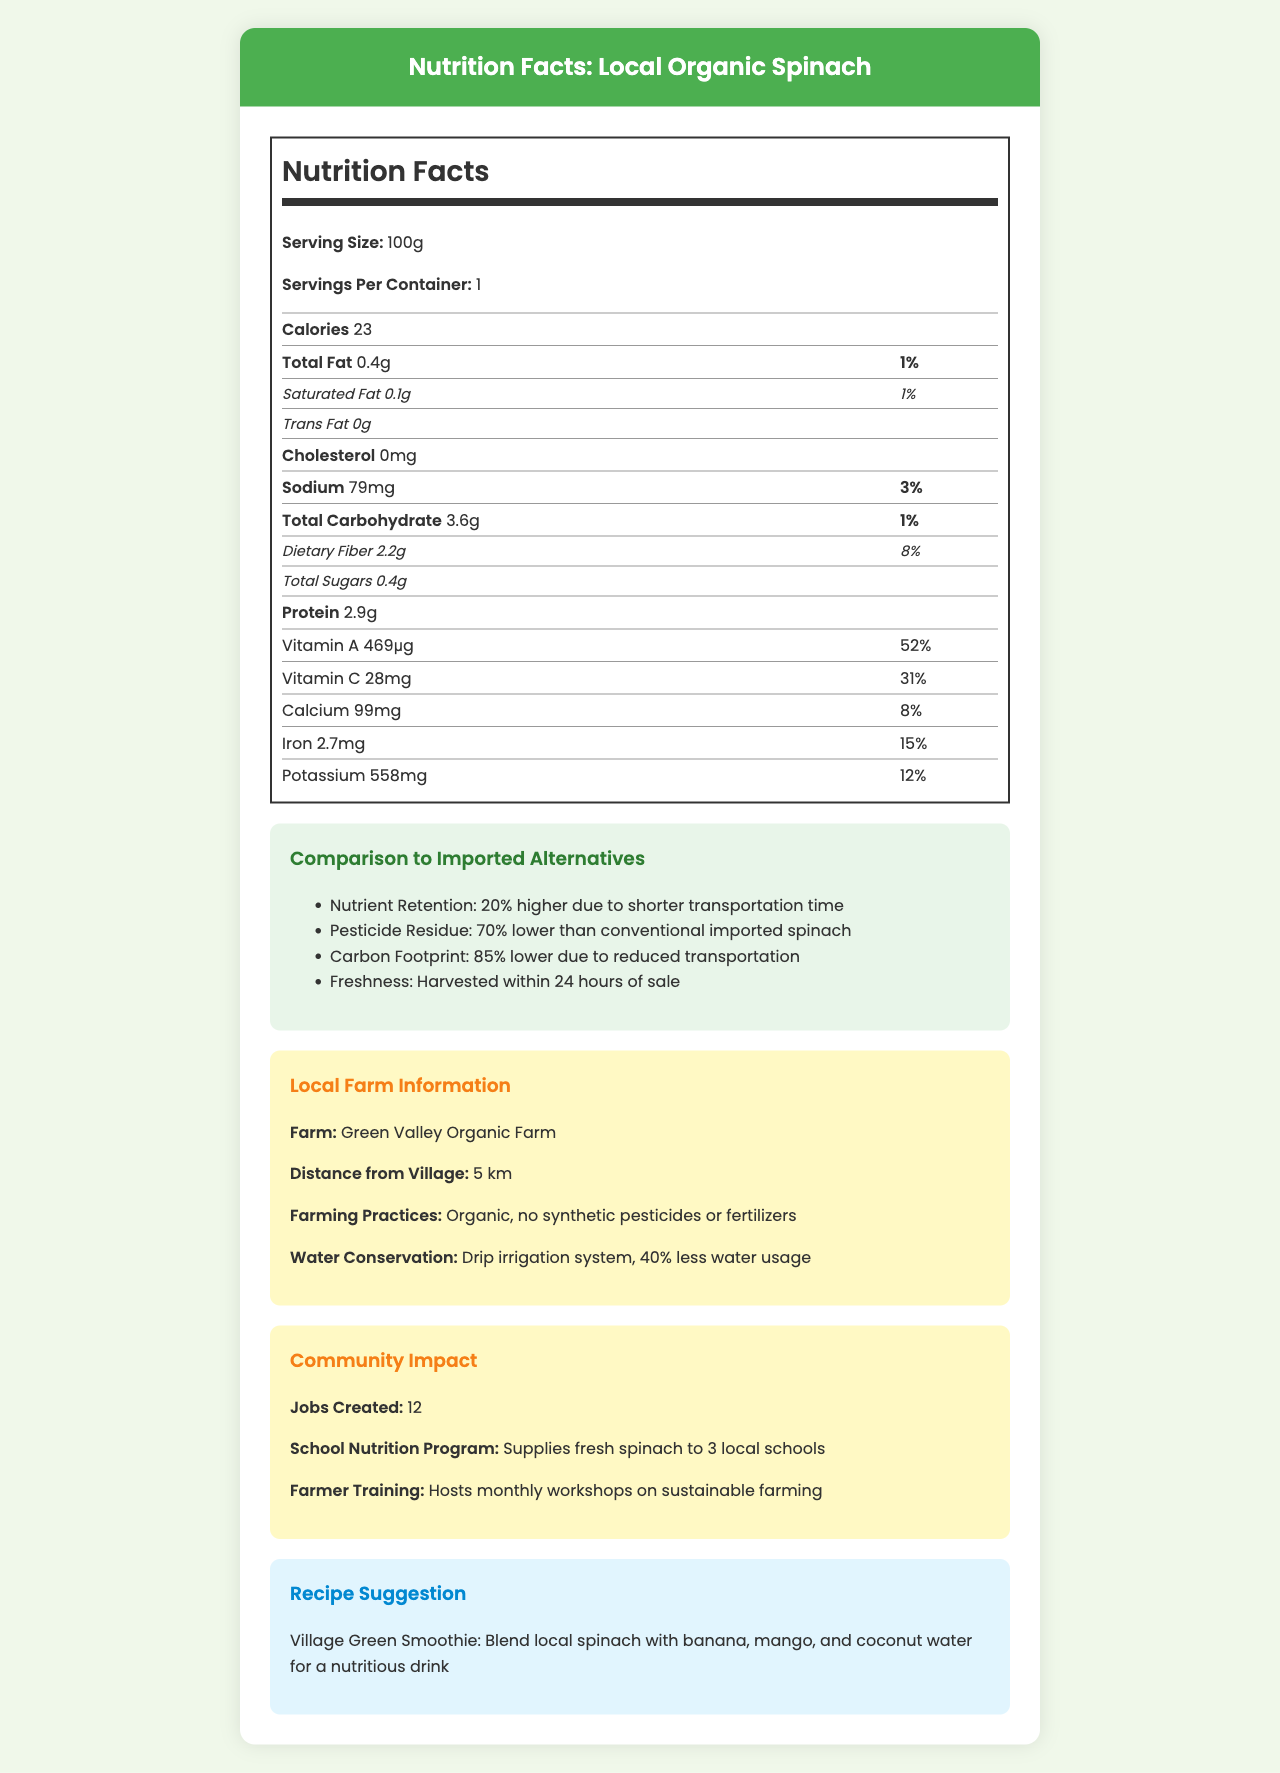What is the serving size of the Local Organic Spinach? The serving size is specified under the "Nutrition Facts" section as "Serving Size: 100g".
Answer: 100g How many calories are in one serving of the Local Organic Spinach? The number of calories is shown under the "Calories" section as "Calories 23".
Answer: 23 What is the sodium content in one serving of the Local Organic Spinach? The sodium content is listed in the nutrition table as "Sodium: 79mg".
Answer: 79mg How much dietary fiber does one serving provide? The amount of dietary fiber is listed in the nutrition table as "Dietary Fiber: 2.2g".
Answer: 2.2g What percentage of the daily value for Vitamin A does one serving of Local Organic Spinach contain? The daily value percentage for Vitamin A is indicated in the nutrition table as "Vitamin A: 52%".
Answer: 52% Which nutrient has a higher retention in the Local Organic Spinach compared to imported alternatives?
A. Vitamin A
B. Protein
C. Carbohydrates While the exact nutritional comparison isn't detailed for each specific nutrient, the document mentions that "Nutrient Retention: 20% higher due to shorter transportation time," which inflates the retention values generally, but the specific nutrient comparison is not directly stated.
Answer: A. Vitamin A What are the farming practices used by Green Valley Organic Farm? The farming practices are detailed in the "Local Farm Information" section as "Organic, no synthetic pesticides or fertilizers".
Answer: Organic, no synthetic pesticides or fertilizers How much lower is the carbon footprint of Local Organic Spinach compared to imported alternatives? The carbon footprint reduction is mentioned in the "Comparison to Imported Alternatives" section as "85% lower due to reduced transportation".
Answer: 85% Does Local Organic Spinach contain any trans fat? The trans fat content is listed as "0g" in the nutrition table.
Answer: No How far is Green Valley Organic Farm from the village? The distance from the village is mentioned in the "Local Farm Information" section as "Distance from Village: 5 km".
Answer: 5 km How many jobs has the production of Local Organic Spinach created in the community? The number of jobs created is listed in the "Community Impact" section as "Jobs Created: 12".
Answer: 12 List one way Green Valley Organic Farm conserves water. The water conservation method is detailed in the "Local Farm Information" section as "Drip irrigation system, 40% less water usage".
Answer: Drip irrigation system, 40% less water usage Summarize the main benefits of choosing Local Organic Spinach over imported alternatives. The document highlights various benefits in the "Comparison to Imported Alternatives" section: "Nutrient Retention: 20% higher due to shorter transportation time," "Pesticide Residue: 70% lower than conventional imported spinach," "Carbon Footprint: 85% lower due to reduced transportation," and "Freshness: Harvested within 24 hours of sale."
Answer: Better nutrient retention, lower pesticide residue, reduced carbon footprint, and greater freshness. Explain the impact of Local Organic Spinach on the community in a few sentences. The "Community Impact" section mentions that 12 jobs were created, fresh spinach is supplied to 3 local schools, and monthly workshops on sustainable farming are hosted by Green Valley Organic Farm.
Answer: It has created jobs, supports school nutrition programs, and hosts farmer training initiatives. What all fresh ingredients are suggested to make the Village Green Smoothie? The "Recipe Suggestion" section mentions blending local spinach with banana, mango, and coconut water for a nutritious drink.
Answer: Spinach, banana, mango, and coconut water How much calcium does one serving of Local Organic Spinach provide? The calcium content is noted in the nutrition table as "Calcium: 99mg."
Answer: 99mg How many schools are supplied with fresh spinach under the school nutrition program? The number of schools supplied is listed under the "Community Impact" section as "Supplies fresh spinach to 3 local schools."
Answer: 3 What is the main color scheme used in the document? The color scheme cannot be determined from the provided text information.
Answer: Cannot be determined. How long before sale is the Local Organic Spinach harvested? The freshness is described in the "Comparison to Imported Alternatives" section as "Harvested within 24 hours of sale."
Answer: Within 24 hours What is the primary source of protein in Local Organic Spinach? The nutritional label lists "Protein: 2.9g," indicating that the spinach is the source of the protein.
Answer: Spinach itself 